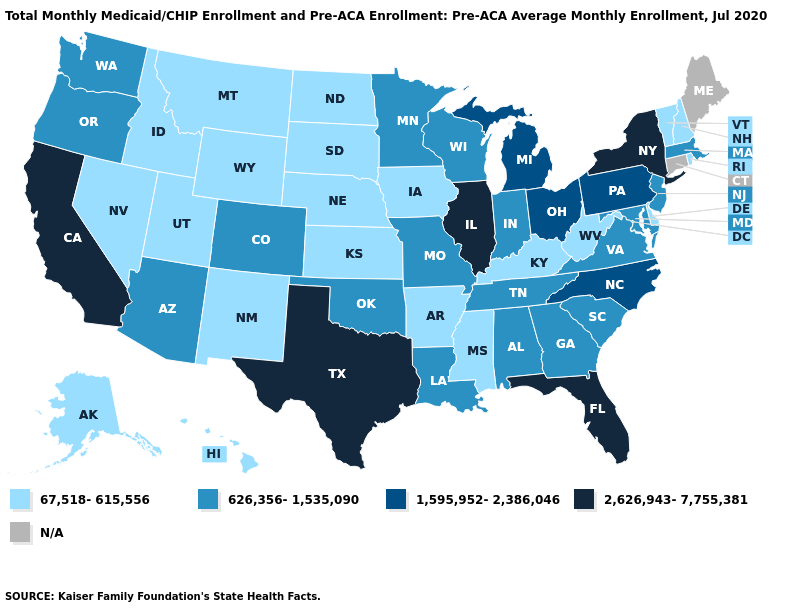Among the states that border Missouri , which have the lowest value?
Answer briefly. Arkansas, Iowa, Kansas, Kentucky, Nebraska. Which states have the lowest value in the South?
Answer briefly. Arkansas, Delaware, Kentucky, Mississippi, West Virginia. Name the states that have a value in the range 2,626,943-7,755,381?
Keep it brief. California, Florida, Illinois, New York, Texas. What is the lowest value in states that border Utah?
Concise answer only. 67,518-615,556. What is the highest value in states that border Washington?
Answer briefly. 626,356-1,535,090. What is the value of South Carolina?
Answer briefly. 626,356-1,535,090. Which states have the lowest value in the West?
Give a very brief answer. Alaska, Hawaii, Idaho, Montana, Nevada, New Mexico, Utah, Wyoming. What is the value of Wisconsin?
Quick response, please. 626,356-1,535,090. Name the states that have a value in the range 2,626,943-7,755,381?
Short answer required. California, Florida, Illinois, New York, Texas. Does Florida have the lowest value in the USA?
Concise answer only. No. Does the first symbol in the legend represent the smallest category?
Keep it brief. Yes. Is the legend a continuous bar?
Keep it brief. No. Which states have the lowest value in the USA?
Concise answer only. Alaska, Arkansas, Delaware, Hawaii, Idaho, Iowa, Kansas, Kentucky, Mississippi, Montana, Nebraska, Nevada, New Hampshire, New Mexico, North Dakota, Rhode Island, South Dakota, Utah, Vermont, West Virginia, Wyoming. 